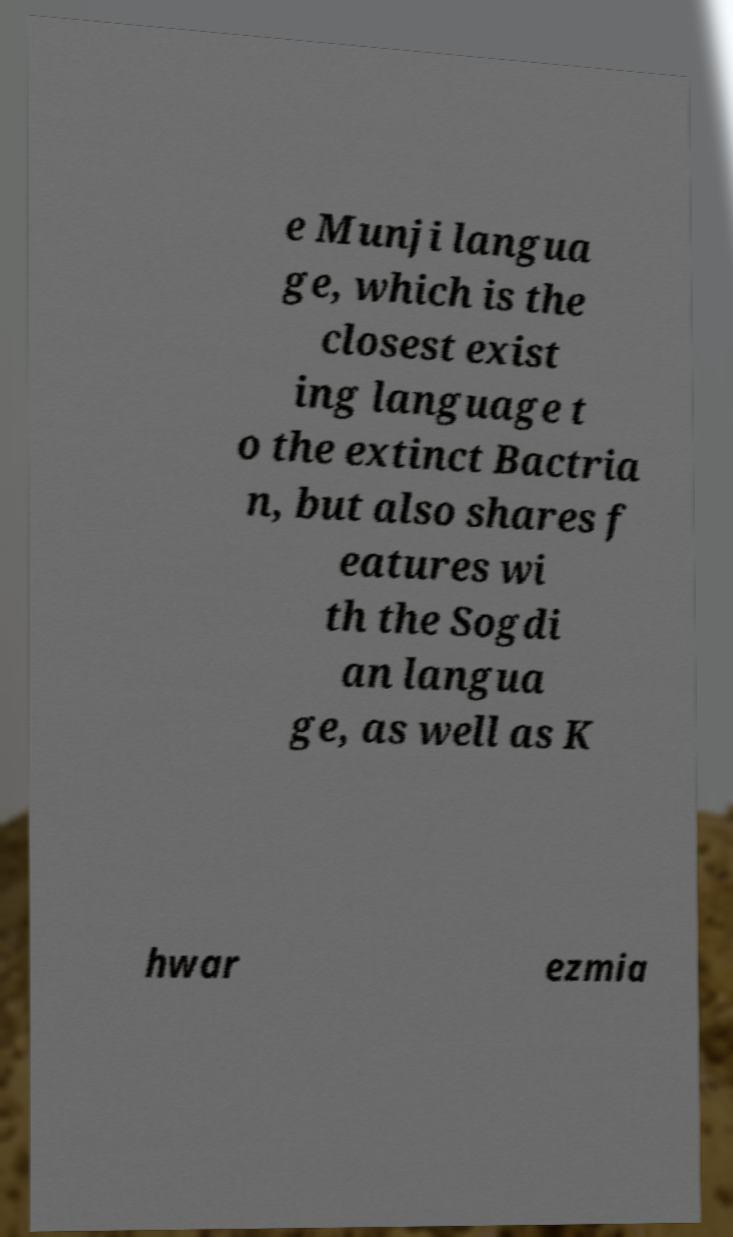Could you extract and type out the text from this image? e Munji langua ge, which is the closest exist ing language t o the extinct Bactria n, but also shares f eatures wi th the Sogdi an langua ge, as well as K hwar ezmia 